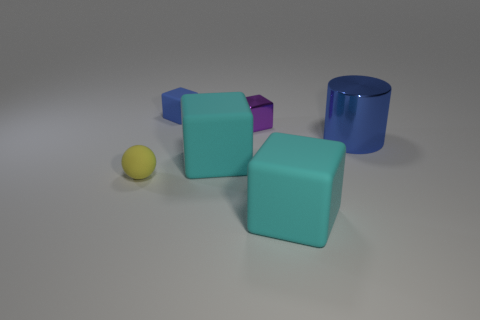Are there fewer big cyan matte objects behind the yellow matte ball than big brown matte blocks?
Offer a very short reply. No. The small thing that is left of the cube that is left of the cyan rubber cube that is left of the purple thing is made of what material?
Keep it short and to the point. Rubber. What number of things are either small rubber objects left of the small blue matte thing or shiny objects behind the cylinder?
Offer a terse response. 2. What is the material of the blue thing that is the same shape as the small purple metal thing?
Give a very brief answer. Rubber. How many rubber things are big blocks or small brown blocks?
Offer a terse response. 2. What shape is the other tiny object that is the same material as the tiny blue thing?
Keep it short and to the point. Sphere. What number of big things have the same shape as the small blue object?
Make the answer very short. 2. Is the shape of the blue thing behind the big cylinder the same as the metal thing behind the blue metallic thing?
Provide a short and direct response. Yes. What number of objects are large cyan metal things or cyan matte cubes that are in front of the tiny yellow rubber object?
Offer a very short reply. 1. What is the shape of the tiny object that is the same color as the shiny cylinder?
Your answer should be compact. Cube. 